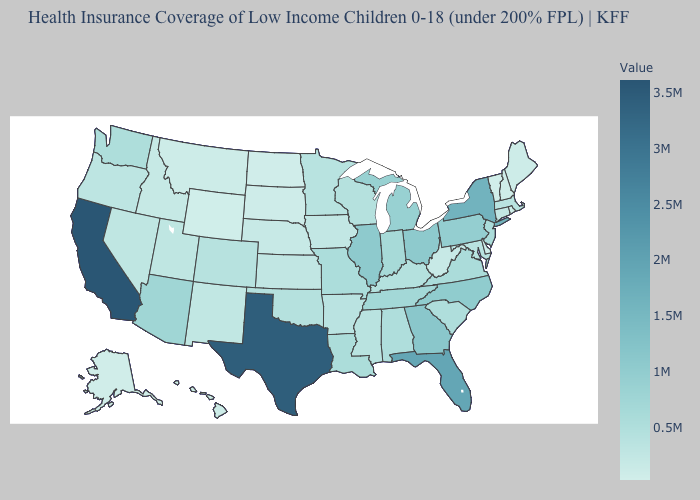Which states have the lowest value in the USA?
Concise answer only. Vermont. Does Alaska have the highest value in the West?
Keep it brief. No. Among the states that border Tennessee , does Arkansas have the highest value?
Be succinct. No. Which states have the highest value in the USA?
Write a very short answer. California. Which states hav the highest value in the South?
Write a very short answer. Texas. Which states have the highest value in the USA?
Give a very brief answer. California. Among the states that border Michigan , which have the lowest value?
Give a very brief answer. Wisconsin. 